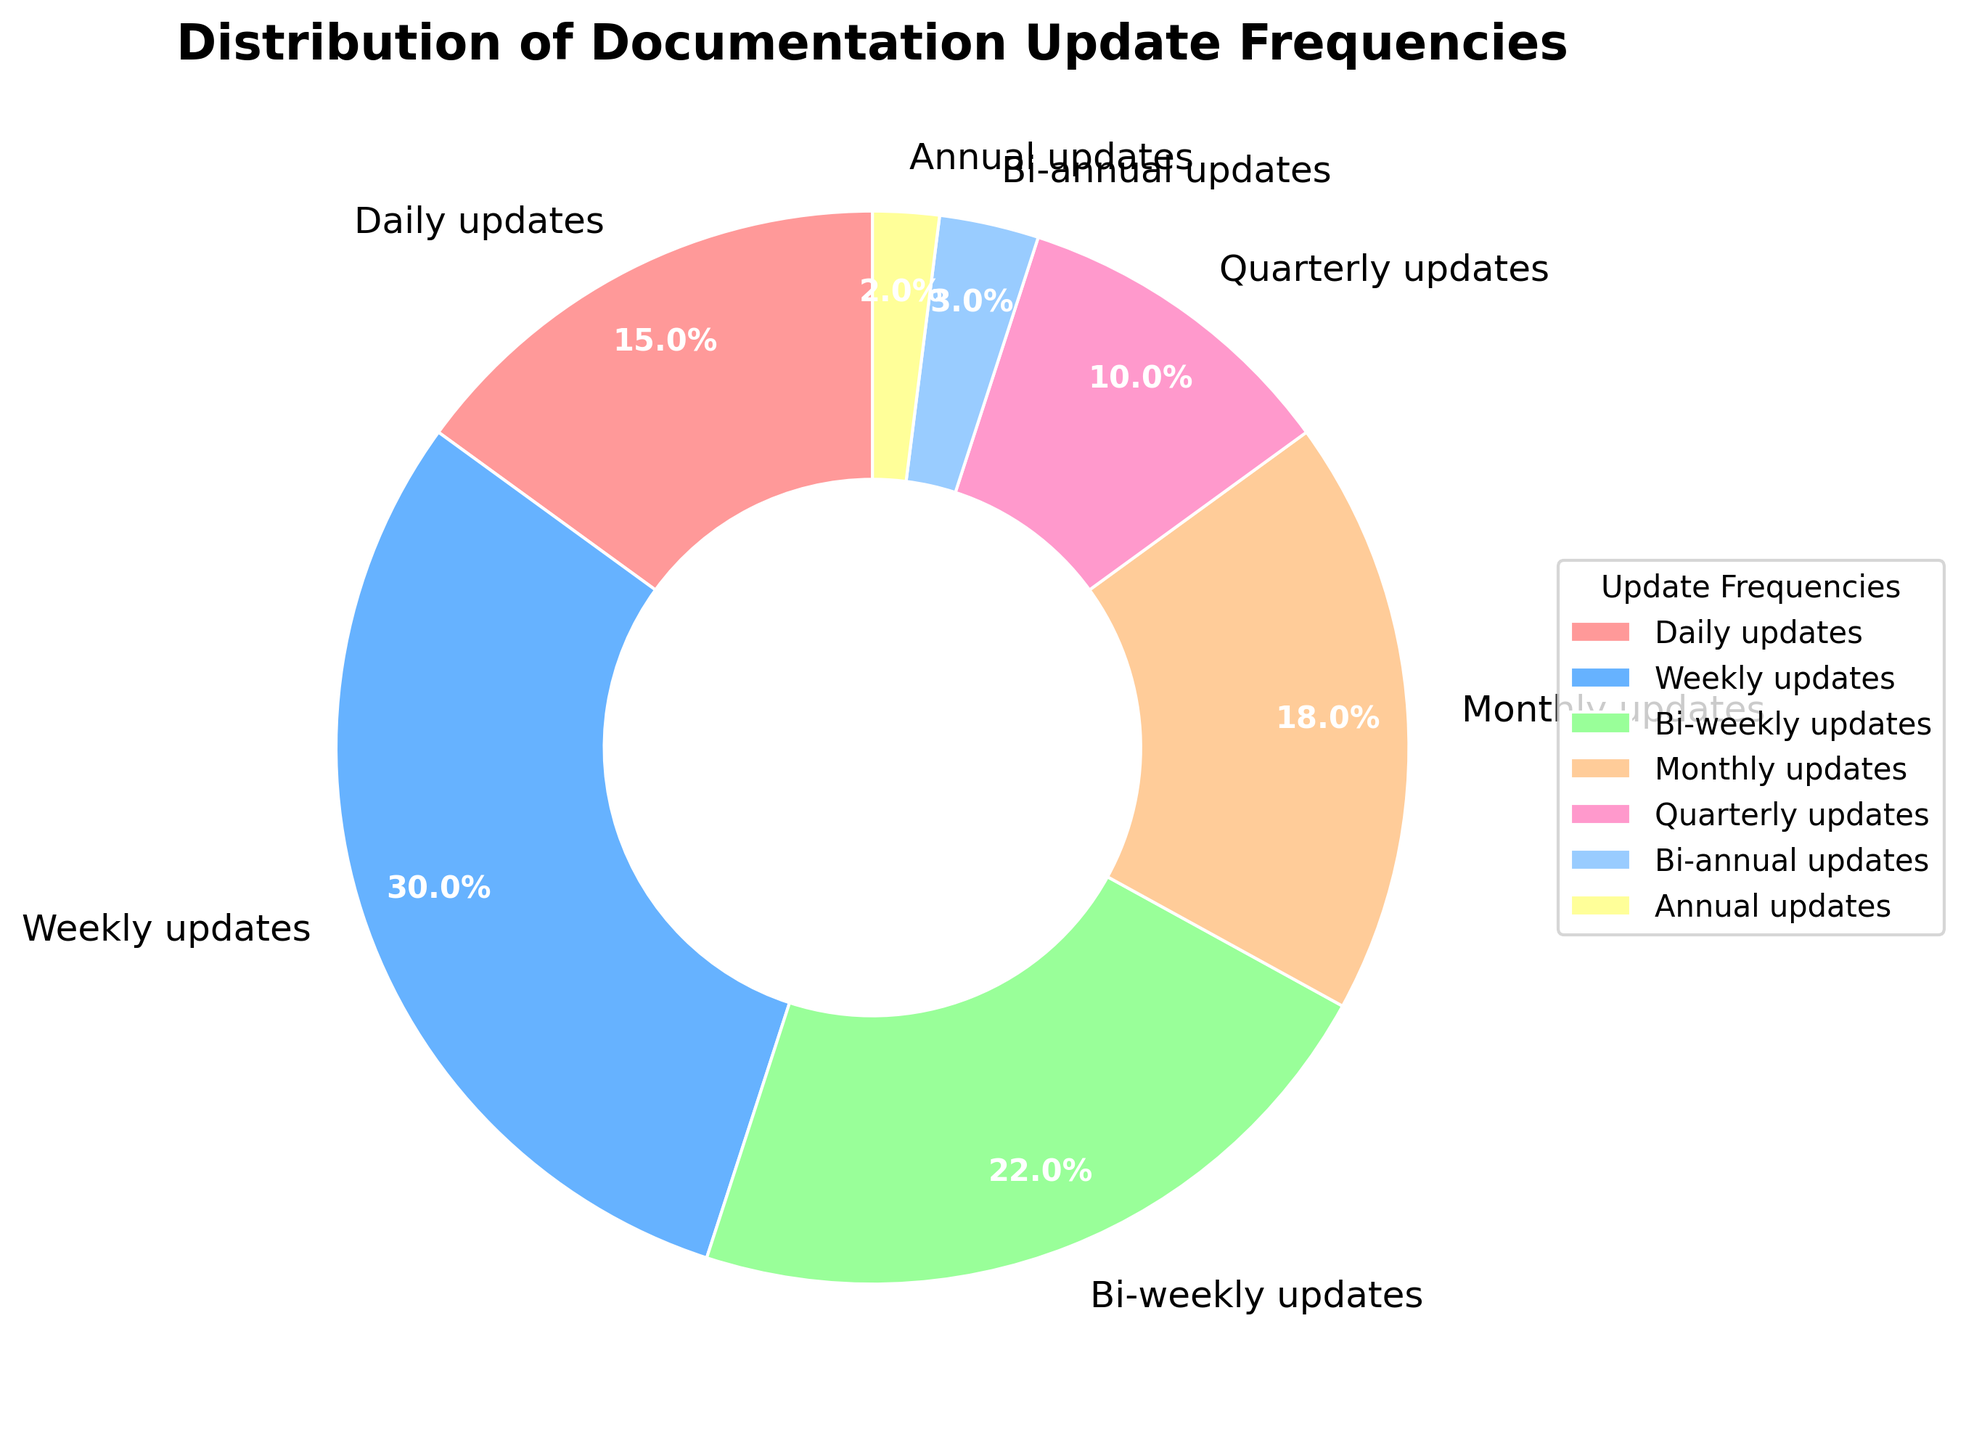What percentage of the updates are made less frequently than bi-weekly? To find this, sum the percentages of monthly, quarterly, bi-annual, and annual updates. Monthly = 18%, Quarterly = 10%, Bi-annual = 3%, Annual = 2%. 18% + 10% + 3% + 2% = 33%
Answer: 33% Which update frequency is the most common based on the pie chart? Look for the slice with the largest percentage in the pie chart. The largest slice corresponds to weekly updates with 30%.
Answer: Weekly updates Are there more frequent updates made daily or bi-weekly? Compare the percentages of daily updates and bi-weekly updates. Daily updates = 15%, Bi-weekly updates = 22%. 22% is greater than 15%.
Answer: Bi-weekly updates What is the combined percentage of updates made on a weekly and bi-weekly basis? Sum the percentages for weekly and bi-weekly updates. Weekly = 30%, Bi-weekly = 22%. 30% + 22% = 52%
Answer: 52% Which update frequencies have the smallest slices in the pie chart? Identify the categories with the smallest percentages. Bi-annual updates = 3% and Annual updates = 2%.
Answer: Bi-annual updates and Annual updates Are monthly updates more frequent than quarterly updates? Compare the percentages of monthly updates and quarterly updates. Monthly updates = 18%, Quarterly updates = 10%. 18% is greater than 10%.
Answer: Yes How does the frequency of daily updates compare to the sum of bi-annual and annual updates? Calculate the sum of bi-annual and annual updates and compare it to daily updates. Bi-annual = 3%, Annual = 2%. Sum is 3% + 2% = 5%. Daily updates = 15%, which is greater than 5%.
Answer: Daily updates are more frequent Which two update frequencies together make up the largest portion of the pie chart? Observe the two largest slices and add their percentages. Weekly updates = 30%, Bi-weekly updates = 22%. Combined is 30% + 22% = 52%.
Answer: Weekly and Bi-weekly updates What fraction of updates are made quarterly or more frequently? Sum the percentages for daily, weekly, bi-weekly, and monthly updates. Daily = 15%, Weekly = 30%, Bi-weekly = 22%, Monthly = 18%. 15% + 30% + 22% + 18% = 85%
Answer: 85% 